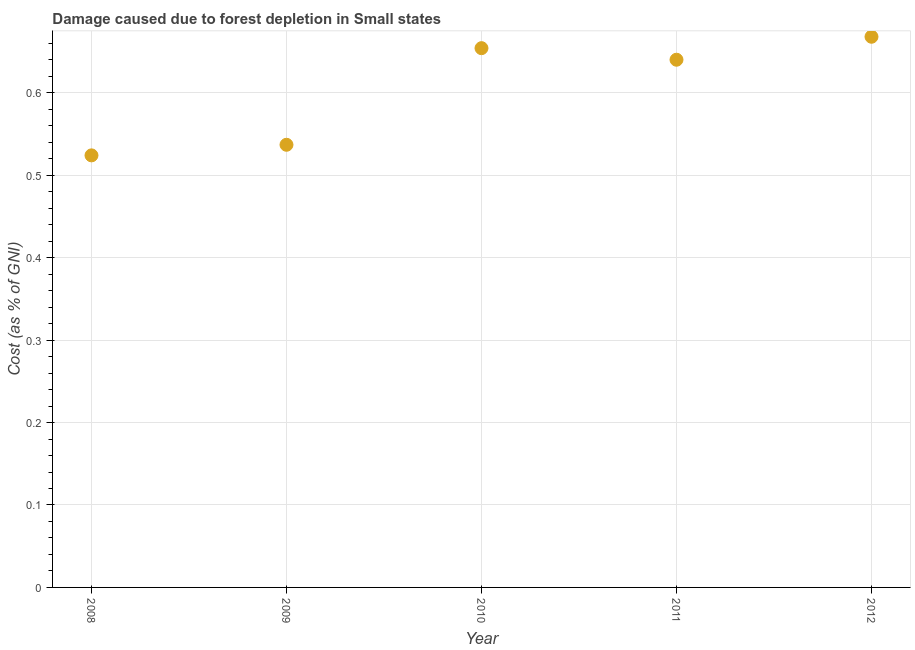What is the damage caused due to forest depletion in 2009?
Offer a terse response. 0.54. Across all years, what is the maximum damage caused due to forest depletion?
Offer a very short reply. 0.67. Across all years, what is the minimum damage caused due to forest depletion?
Your answer should be compact. 0.52. In which year was the damage caused due to forest depletion minimum?
Keep it short and to the point. 2008. What is the sum of the damage caused due to forest depletion?
Ensure brevity in your answer.  3.02. What is the difference between the damage caused due to forest depletion in 2008 and 2009?
Ensure brevity in your answer.  -0.01. What is the average damage caused due to forest depletion per year?
Your answer should be compact. 0.6. What is the median damage caused due to forest depletion?
Provide a succinct answer. 0.64. In how many years, is the damage caused due to forest depletion greater than 0.6000000000000001 %?
Offer a terse response. 3. What is the ratio of the damage caused due to forest depletion in 2008 to that in 2011?
Your answer should be compact. 0.82. Is the damage caused due to forest depletion in 2011 less than that in 2012?
Provide a succinct answer. Yes. Is the difference between the damage caused due to forest depletion in 2011 and 2012 greater than the difference between any two years?
Ensure brevity in your answer.  No. What is the difference between the highest and the second highest damage caused due to forest depletion?
Give a very brief answer. 0.01. What is the difference between the highest and the lowest damage caused due to forest depletion?
Offer a terse response. 0.14. Does the damage caused due to forest depletion monotonically increase over the years?
Keep it short and to the point. No. Are the values on the major ticks of Y-axis written in scientific E-notation?
Offer a very short reply. No. Does the graph contain any zero values?
Offer a terse response. No. Does the graph contain grids?
Give a very brief answer. Yes. What is the title of the graph?
Give a very brief answer. Damage caused due to forest depletion in Small states. What is the label or title of the X-axis?
Offer a very short reply. Year. What is the label or title of the Y-axis?
Keep it short and to the point. Cost (as % of GNI). What is the Cost (as % of GNI) in 2008?
Your answer should be very brief. 0.52. What is the Cost (as % of GNI) in 2009?
Ensure brevity in your answer.  0.54. What is the Cost (as % of GNI) in 2010?
Make the answer very short. 0.65. What is the Cost (as % of GNI) in 2011?
Offer a very short reply. 0.64. What is the Cost (as % of GNI) in 2012?
Provide a short and direct response. 0.67. What is the difference between the Cost (as % of GNI) in 2008 and 2009?
Your answer should be very brief. -0.01. What is the difference between the Cost (as % of GNI) in 2008 and 2010?
Make the answer very short. -0.13. What is the difference between the Cost (as % of GNI) in 2008 and 2011?
Offer a very short reply. -0.12. What is the difference between the Cost (as % of GNI) in 2008 and 2012?
Keep it short and to the point. -0.14. What is the difference between the Cost (as % of GNI) in 2009 and 2010?
Your answer should be compact. -0.12. What is the difference between the Cost (as % of GNI) in 2009 and 2011?
Keep it short and to the point. -0.1. What is the difference between the Cost (as % of GNI) in 2009 and 2012?
Give a very brief answer. -0.13. What is the difference between the Cost (as % of GNI) in 2010 and 2011?
Provide a succinct answer. 0.01. What is the difference between the Cost (as % of GNI) in 2010 and 2012?
Make the answer very short. -0.01. What is the difference between the Cost (as % of GNI) in 2011 and 2012?
Provide a short and direct response. -0.03. What is the ratio of the Cost (as % of GNI) in 2008 to that in 2009?
Your answer should be very brief. 0.98. What is the ratio of the Cost (as % of GNI) in 2008 to that in 2010?
Your answer should be compact. 0.8. What is the ratio of the Cost (as % of GNI) in 2008 to that in 2011?
Keep it short and to the point. 0.82. What is the ratio of the Cost (as % of GNI) in 2008 to that in 2012?
Provide a succinct answer. 0.79. What is the ratio of the Cost (as % of GNI) in 2009 to that in 2010?
Give a very brief answer. 0.82. What is the ratio of the Cost (as % of GNI) in 2009 to that in 2011?
Your answer should be compact. 0.84. What is the ratio of the Cost (as % of GNI) in 2009 to that in 2012?
Ensure brevity in your answer.  0.8. What is the ratio of the Cost (as % of GNI) in 2010 to that in 2011?
Offer a very short reply. 1.02. What is the ratio of the Cost (as % of GNI) in 2010 to that in 2012?
Your answer should be compact. 0.98. What is the ratio of the Cost (as % of GNI) in 2011 to that in 2012?
Offer a very short reply. 0.96. 